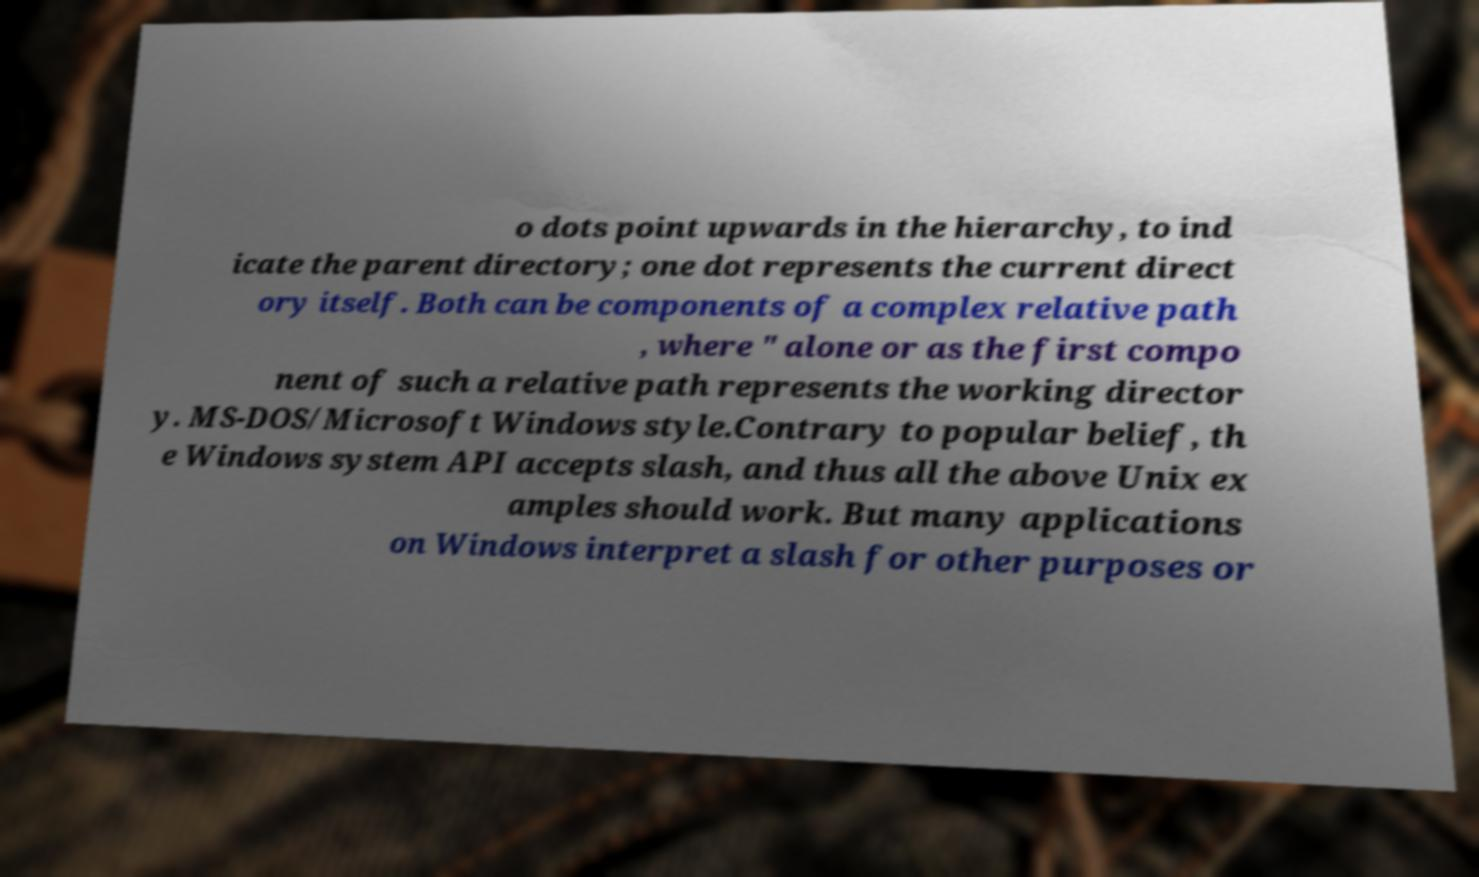Could you assist in decoding the text presented in this image and type it out clearly? o dots point upwards in the hierarchy, to ind icate the parent directory; one dot represents the current direct ory itself. Both can be components of a complex relative path , where " alone or as the first compo nent of such a relative path represents the working director y. MS-DOS/Microsoft Windows style.Contrary to popular belief, th e Windows system API accepts slash, and thus all the above Unix ex amples should work. But many applications on Windows interpret a slash for other purposes or 